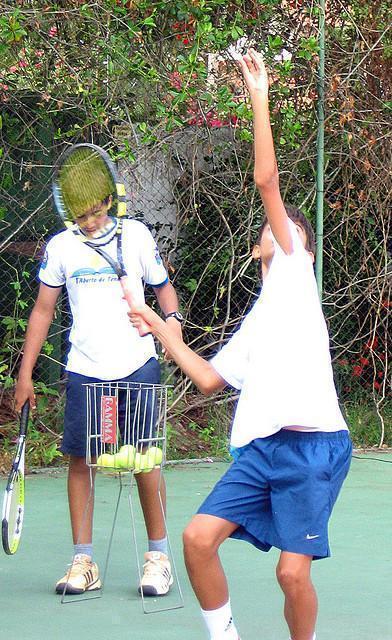What color are the interior nettings of the rackets used by the two men?
Indicate the correct choice and explain in the format: 'Answer: answer
Rationale: rationale.'
Options: White, blue, red, green. Answer: green.
Rationale: The rackets are branded by green as a preference form the racket maker. 